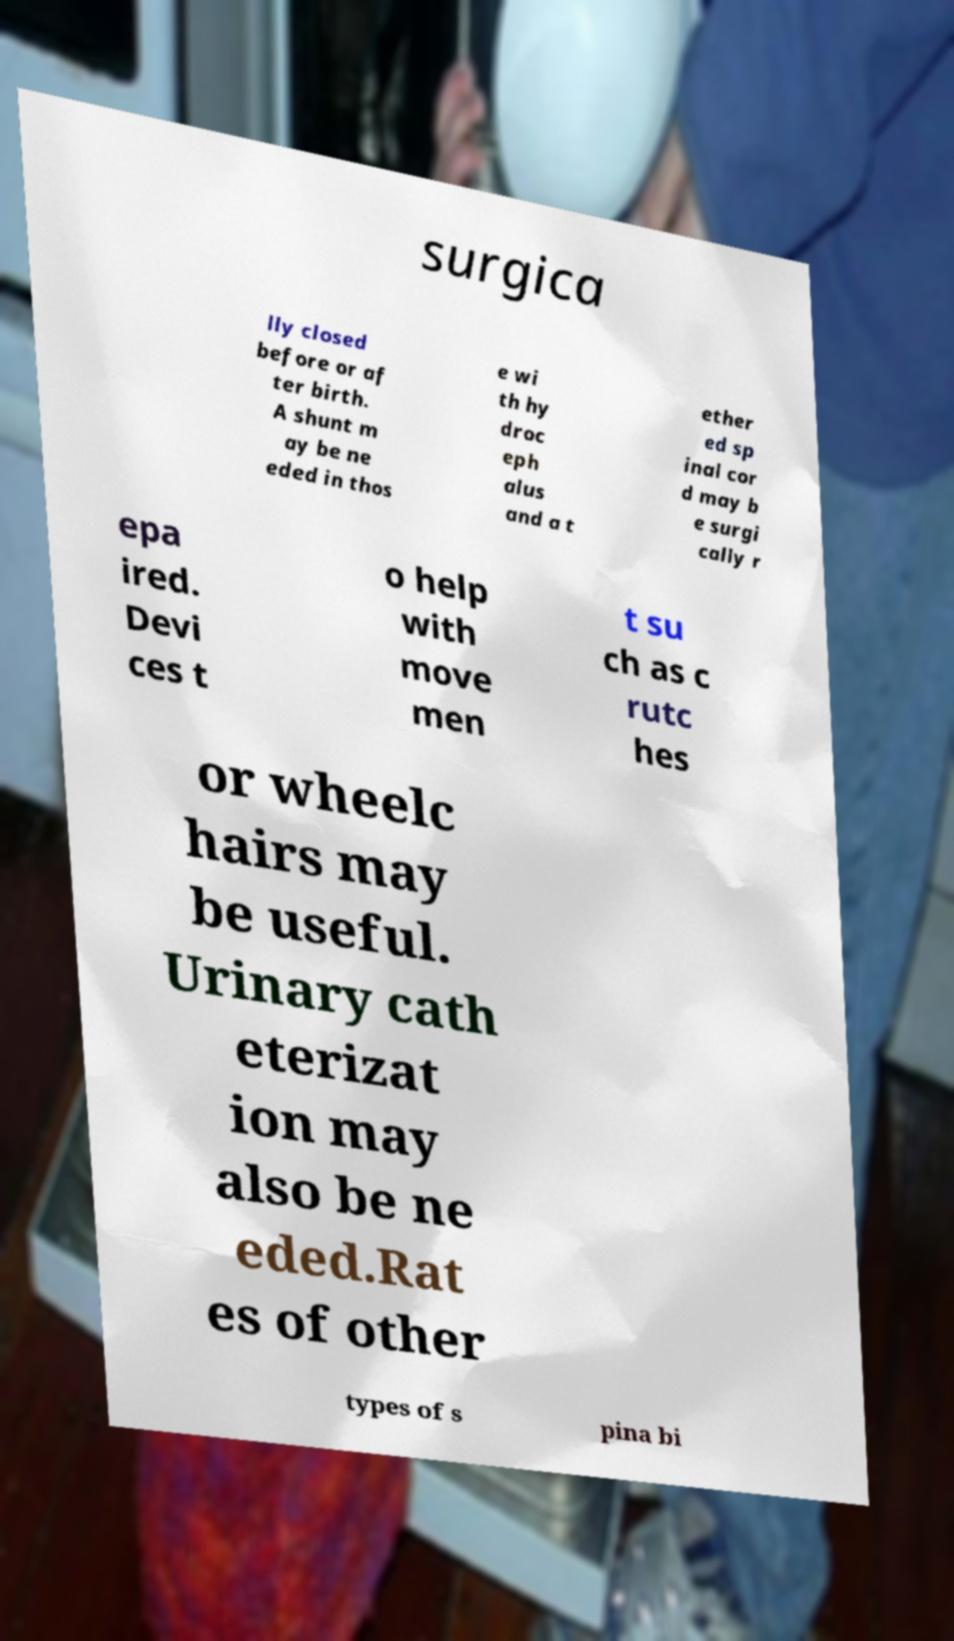What messages or text are displayed in this image? I need them in a readable, typed format. surgica lly closed before or af ter birth. A shunt m ay be ne eded in thos e wi th hy droc eph alus and a t ether ed sp inal cor d may b e surgi cally r epa ired. Devi ces t o help with move men t su ch as c rutc hes or wheelc hairs may be useful. Urinary cath eterizat ion may also be ne eded.Rat es of other types of s pina bi 